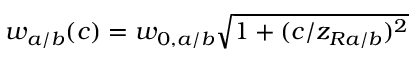Convert formula to latex. <formula><loc_0><loc_0><loc_500><loc_500>w _ { a / b } ( c ) = w _ { 0 , a / b } \sqrt { 1 + ( c / z _ { R a / b } ) ^ { 2 } }</formula> 